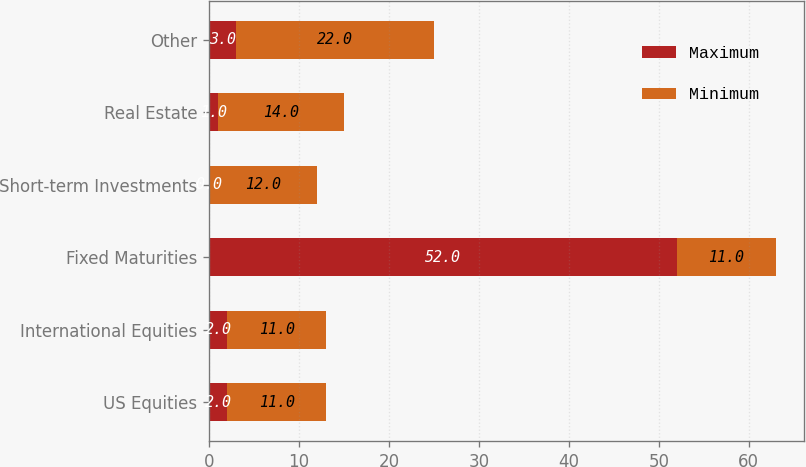Convert chart. <chart><loc_0><loc_0><loc_500><loc_500><stacked_bar_chart><ecel><fcel>US Equities<fcel>International Equities<fcel>Fixed Maturities<fcel>Short-term Investments<fcel>Real Estate<fcel>Other<nl><fcel>Maximum<fcel>2<fcel>2<fcel>52<fcel>0<fcel>1<fcel>3<nl><fcel>Minimum<fcel>11<fcel>11<fcel>11<fcel>12<fcel>14<fcel>22<nl></chart> 